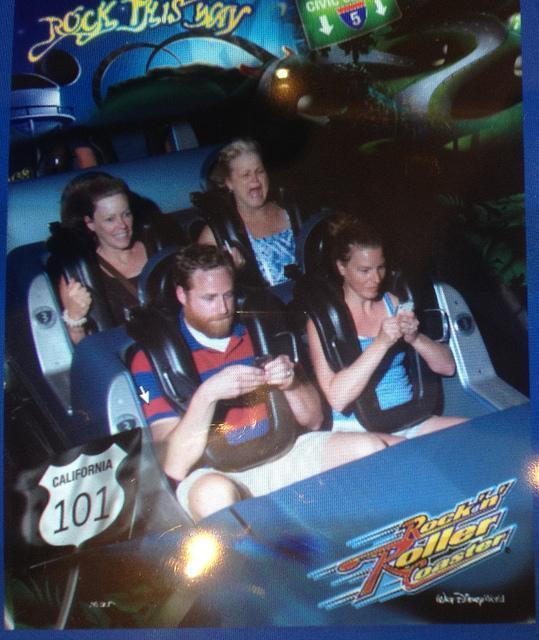How many people are shown on the ride?
Give a very brief answer. 4. How many people are visible?
Give a very brief answer. 4. How many cars in this picture are white?
Give a very brief answer. 0. 